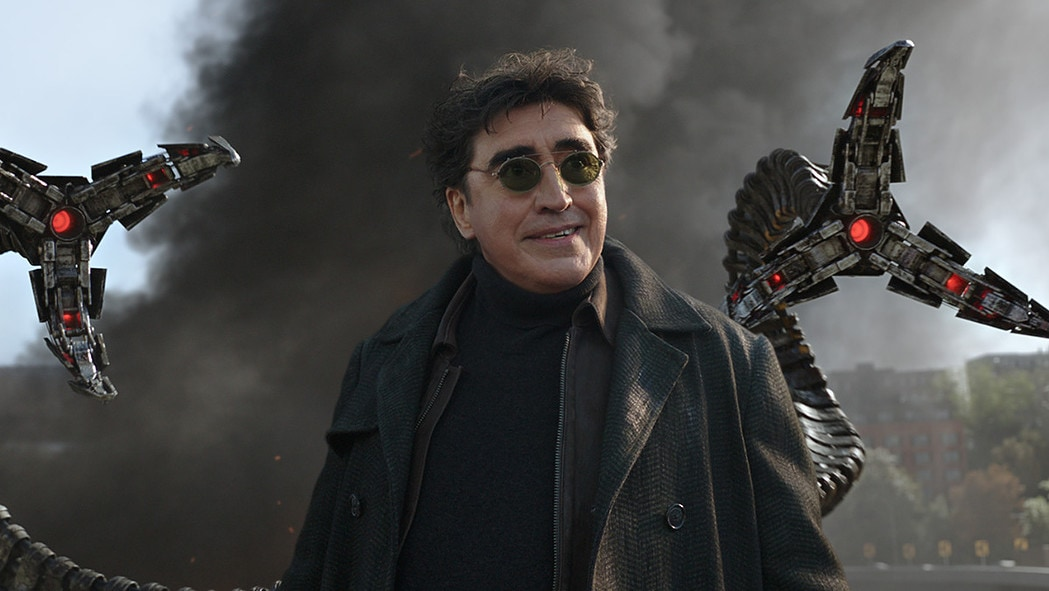Create a scenario where Doctor Octopus must team up with Spider-Man to defeat a greater threat. In a startling turn of events, the alien symbiote Carnage invades New York City, posing a threat too immense for Spider-Man to handle alone. Realizing the severity of the situation, Spider-Man reluctantly seeks the aid of his former foe, Doctor Octopus. Despite their uneasy alliance, the two quickly come to an understanding: their combined strengths are necessary to save the city from annihilation. Doctor Octopus uses his vast scientific knowledge to engineer devices that can temporarily weaken the symbiote's hold, while Spider-Man uses his agility and combat skills to engage Carnage directly. Their teamwork culminates in a climactic battle atop a skyscraper, where Octavius’s tentacles provide support and protection for Spider-Man as he delivers the final blow. The battle is fierce and grueling, but their combined efforts ultimately subdue Carnage, saving the city from destruction. What strategies do they use to weaken Carnage? Doctor Octopus and Spider-Man develop a multi-faceted strategy to weaken Carnage. Octavius devises a sonic frequency device capable of destabilizing the symbiote's molecular structure, exploiting its vulnerability to sound. Spider-Man uses his agility to lure Carnage into confined spaces, where Octavius deploys high-frequency sonic bursts from strategically placed emitters. Additionally, Octavius creates specialized webbing infused with a formula that temporarily disrupts the symbiote's connectivity. Using these tools, they execute a coordinated attack: Spider-Man entangles Carnage with the specialized webbing, immobilizing him momentarily, while Octavius's sonic devices weaken the symbiote's hold. This concerted effort slowly diminishes Carnage's strength, allowing them to overtake him. Narrate how the final blow is delivered. As the battle reaches its peak, Spider-Man and Doctor Octopus corner Carnage on the edge of a skyscraper rooftop. Their combined sonic assault has weakened the symbiote, but Carnage still fights ferociously, his tendrils striking out wildly. With precise coordination, Doctor Octopus uses his tentacles to ensnare Carnage, restraining him with a vice-like grip. Spider-Man seizes the opportunity, swinging in from above with a canister of Octavius's specially formulated chemical. With a final leap, Spider-Man douses Carnage with the chemical, causing the symbiote to writhe and weaken. Octavius intensifies the sonic frequency, rendering the symbiote powerless. In a last surge of heroic effort, Spider-Man delivers a powerful punch to the now vulnerable host, knocking Carnage unconscious. The symbiote begins to disintegrate, leaving behind the defeated host. Together, they secure the antagonist, ensuring he can never threaten the city again. 